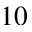Convert formula to latex. <formula><loc_0><loc_0><loc_500><loc_500>1 0</formula> 